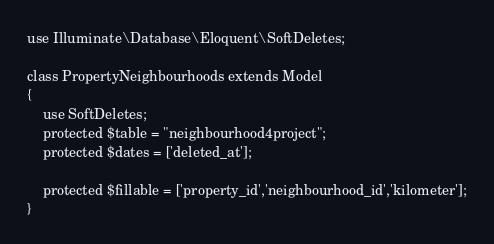<code> <loc_0><loc_0><loc_500><loc_500><_PHP_>use Illuminate\Database\Eloquent\SoftDeletes;

class PropertyNeighbourhoods extends Model
{
    use SoftDeletes;
    protected $table = "neighbourhood4project"; 
    protected $dates = ['deleted_at']; 

    protected $fillable = ['property_id','neighbourhood_id','kilometer'];
}
</code> 